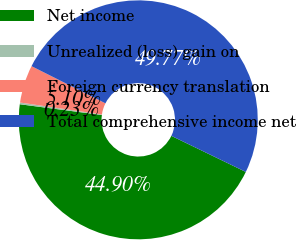Convert chart to OTSL. <chart><loc_0><loc_0><loc_500><loc_500><pie_chart><fcel>Net income<fcel>Unrealized (loss) gain on<fcel>Foreign currency translation<fcel>Total comprehensive income net<nl><fcel>44.9%<fcel>0.23%<fcel>5.1%<fcel>49.77%<nl></chart> 